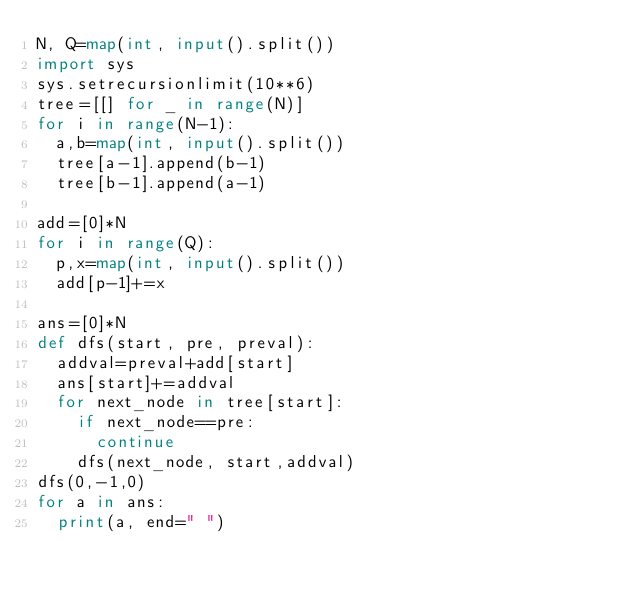Convert code to text. <code><loc_0><loc_0><loc_500><loc_500><_Python_>N, Q=map(int, input().split())
import sys
sys.setrecursionlimit(10**6)
tree=[[] for _ in range(N)]
for i in range(N-1):
  a,b=map(int, input().split())
  tree[a-1].append(b-1)
  tree[b-1].append(a-1)

add=[0]*N
for i in range(Q):
  p,x=map(int, input().split())
  add[p-1]+=x

ans=[0]*N
def dfs(start, pre, preval):
  addval=preval+add[start]
  ans[start]+=addval
  for next_node in tree[start]:
    if next_node==pre:
      continue
    dfs(next_node, start,addval)
dfs(0,-1,0)  
for a in ans:
  print(a, end=" ")
</code> 